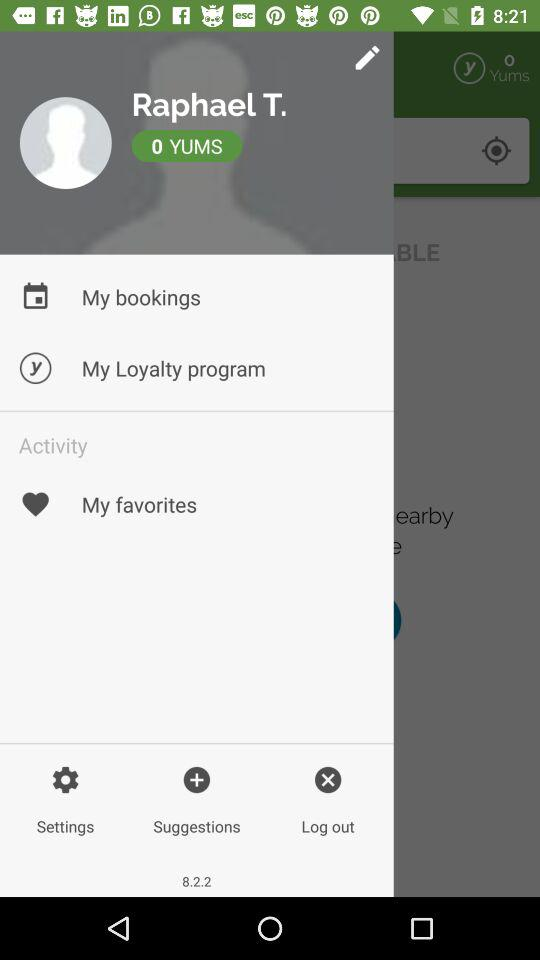What is the user name? The user name is Raphael T. 